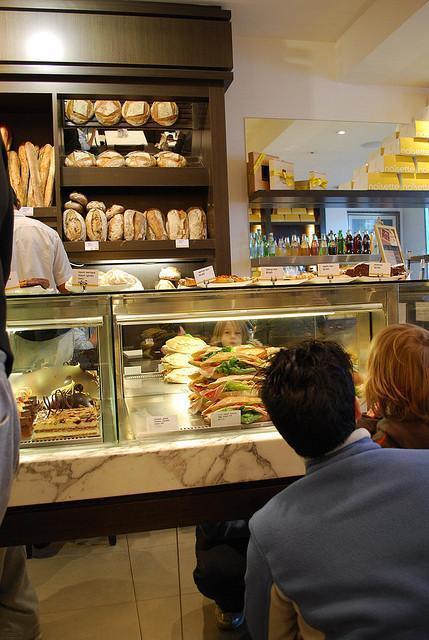How many people are there?
Give a very brief answer. 4. 